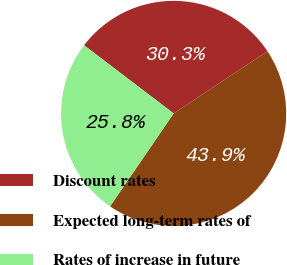Convert chart to OTSL. <chart><loc_0><loc_0><loc_500><loc_500><pie_chart><fcel>Discount rates<fcel>Expected long-term rates of<fcel>Rates of increase in future<nl><fcel>30.34%<fcel>43.86%<fcel>25.8%<nl></chart> 